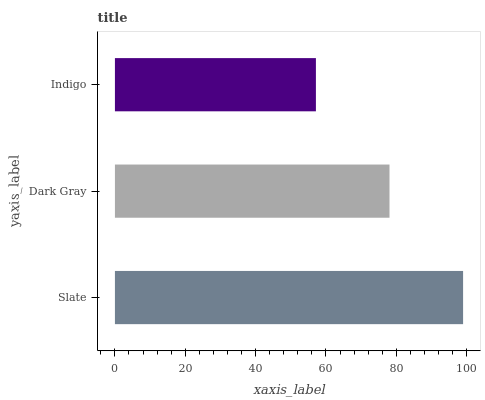Is Indigo the minimum?
Answer yes or no. Yes. Is Slate the maximum?
Answer yes or no. Yes. Is Dark Gray the minimum?
Answer yes or no. No. Is Dark Gray the maximum?
Answer yes or no. No. Is Slate greater than Dark Gray?
Answer yes or no. Yes. Is Dark Gray less than Slate?
Answer yes or no. Yes. Is Dark Gray greater than Slate?
Answer yes or no. No. Is Slate less than Dark Gray?
Answer yes or no. No. Is Dark Gray the high median?
Answer yes or no. Yes. Is Dark Gray the low median?
Answer yes or no. Yes. Is Indigo the high median?
Answer yes or no. No. Is Slate the low median?
Answer yes or no. No. 